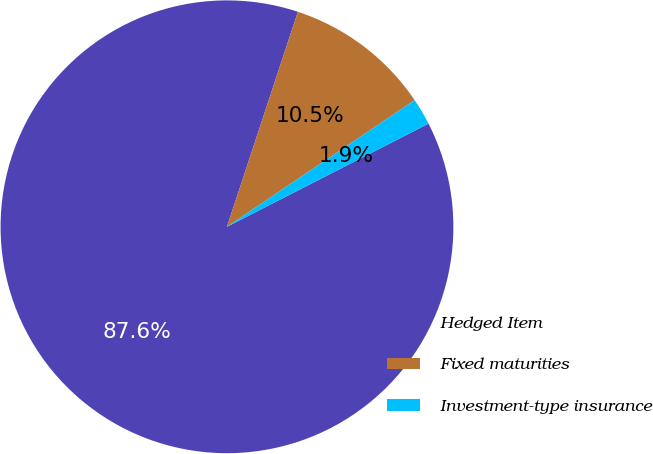Convert chart. <chart><loc_0><loc_0><loc_500><loc_500><pie_chart><fcel>Hedged Item<fcel>Fixed maturities<fcel>Investment-type insurance<nl><fcel>87.6%<fcel>10.48%<fcel>1.92%<nl></chart> 